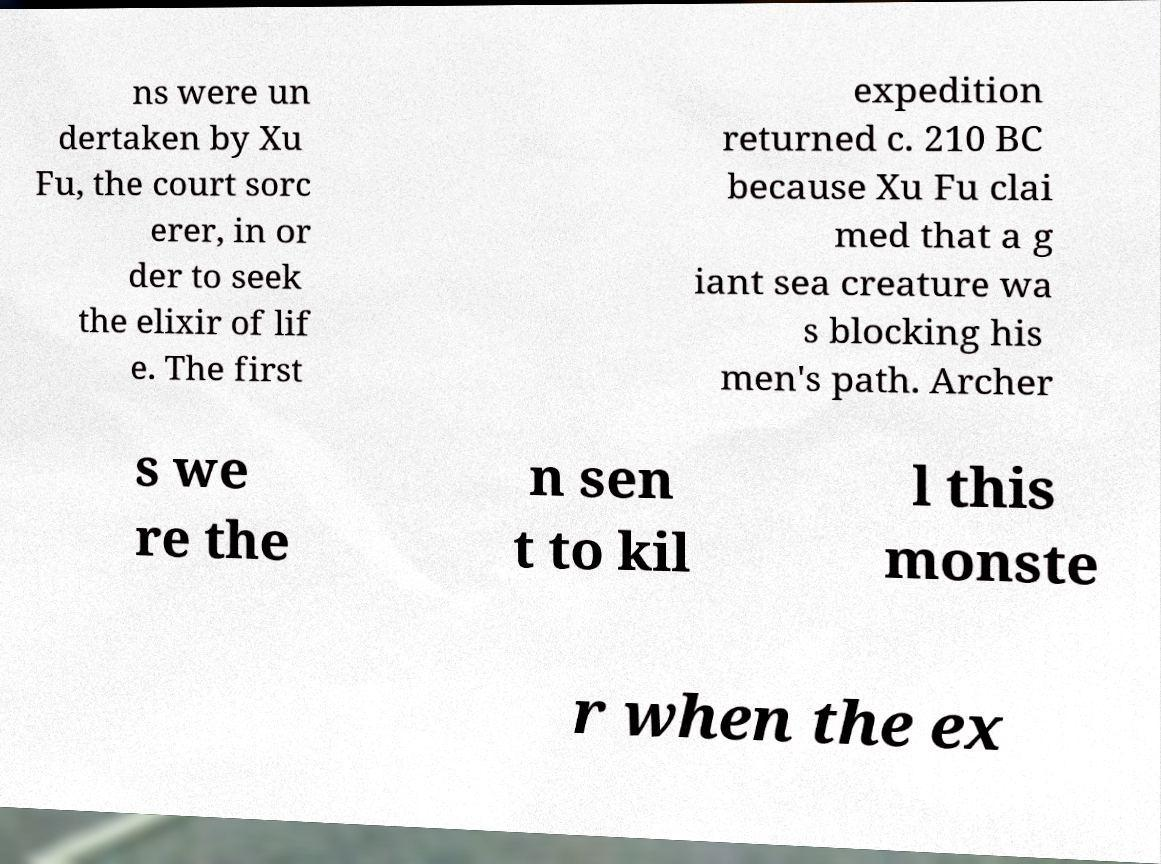What messages or text are displayed in this image? I need them in a readable, typed format. ns were un dertaken by Xu Fu, the court sorc erer, in or der to seek the elixir of lif e. The first expedition returned c. 210 BC because Xu Fu clai med that a g iant sea creature wa s blocking his men's path. Archer s we re the n sen t to kil l this monste r when the ex 